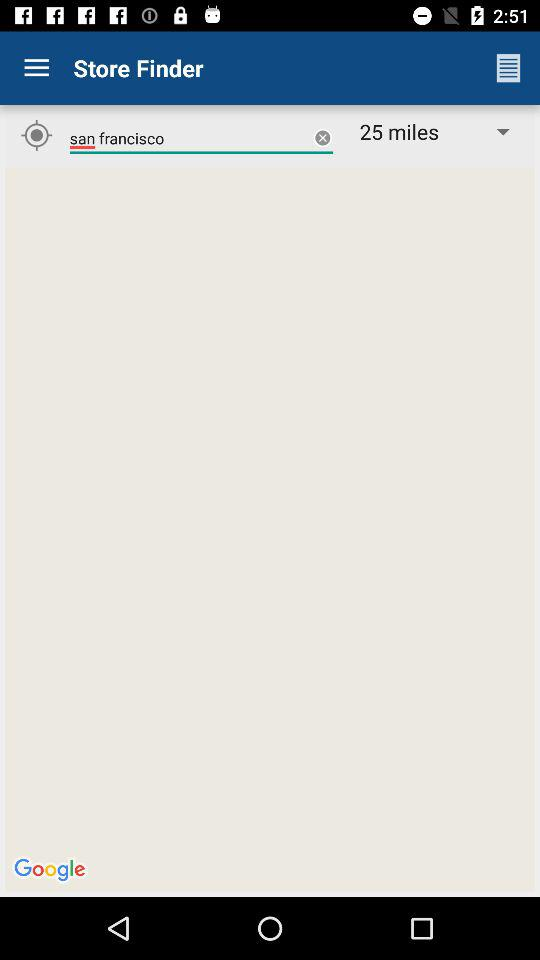What is the distance? The distance is 25 miles. 